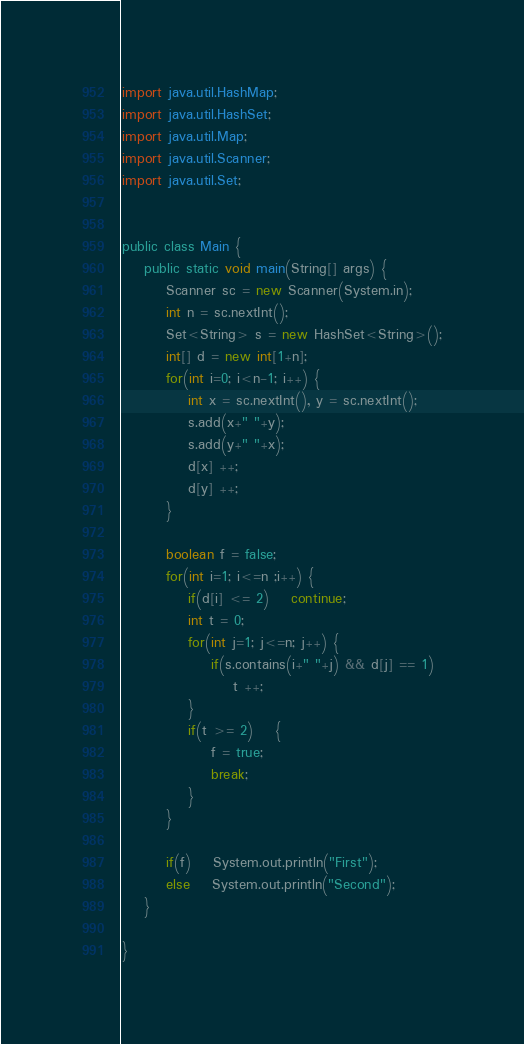Convert code to text. <code><loc_0><loc_0><loc_500><loc_500><_Java_>import java.util.HashMap;
import java.util.HashSet;
import java.util.Map;
import java.util.Scanner;
import java.util.Set;


public class Main {
	public static void main(String[] args) {
		Scanner sc = new Scanner(System.in);
		int n = sc.nextInt();
		Set<String> s = new HashSet<String>();
		int[] d = new int[1+n];
		for(int i=0; i<n-1; i++) {
			int x = sc.nextInt(), y = sc.nextInt();
			s.add(x+" "+y);
			s.add(y+" "+x);
			d[x] ++;
			d[y] ++;
		}
		
		boolean f = false;
		for(int i=1; i<=n ;i++) {
			if(d[i] <= 2)	continue;
			int t = 0;
			for(int j=1; j<=n; j++) {
				if(s.contains(i+" "+j) && d[j] == 1)
					t ++;
			}
			if(t >= 2)	{
				f = true;
				break;
			}
		}
		
		if(f) 	System.out.println("First");
		else	System.out.println("Second");
	}
	
}
</code> 